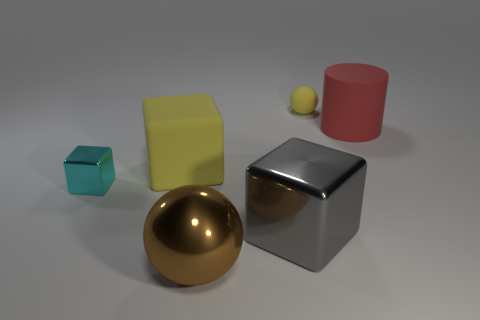Are there any other things that are the same shape as the red rubber thing?
Provide a short and direct response. No. The big thing that is made of the same material as the red cylinder is what shape?
Your response must be concise. Cube. There is a object behind the big matte object that is behind the big yellow matte thing; what number of spheres are in front of it?
Keep it short and to the point. 1. There is a rubber object that is both left of the red matte thing and right of the gray block; what is its shape?
Your answer should be very brief. Sphere. Are there fewer red rubber objects that are in front of the large yellow matte object than small gray matte cylinders?
Your response must be concise. No. What number of large objects are either red objects or brown spheres?
Make the answer very short. 2. The red matte cylinder is what size?
Make the answer very short. Large. What number of cyan objects are behind the small cyan block?
Your answer should be compact. 0. What is the size of the yellow matte thing that is the same shape as the big gray thing?
Make the answer very short. Large. There is a cube that is in front of the big yellow object and to the right of the small metal cube; what is its size?
Offer a very short reply. Large. 